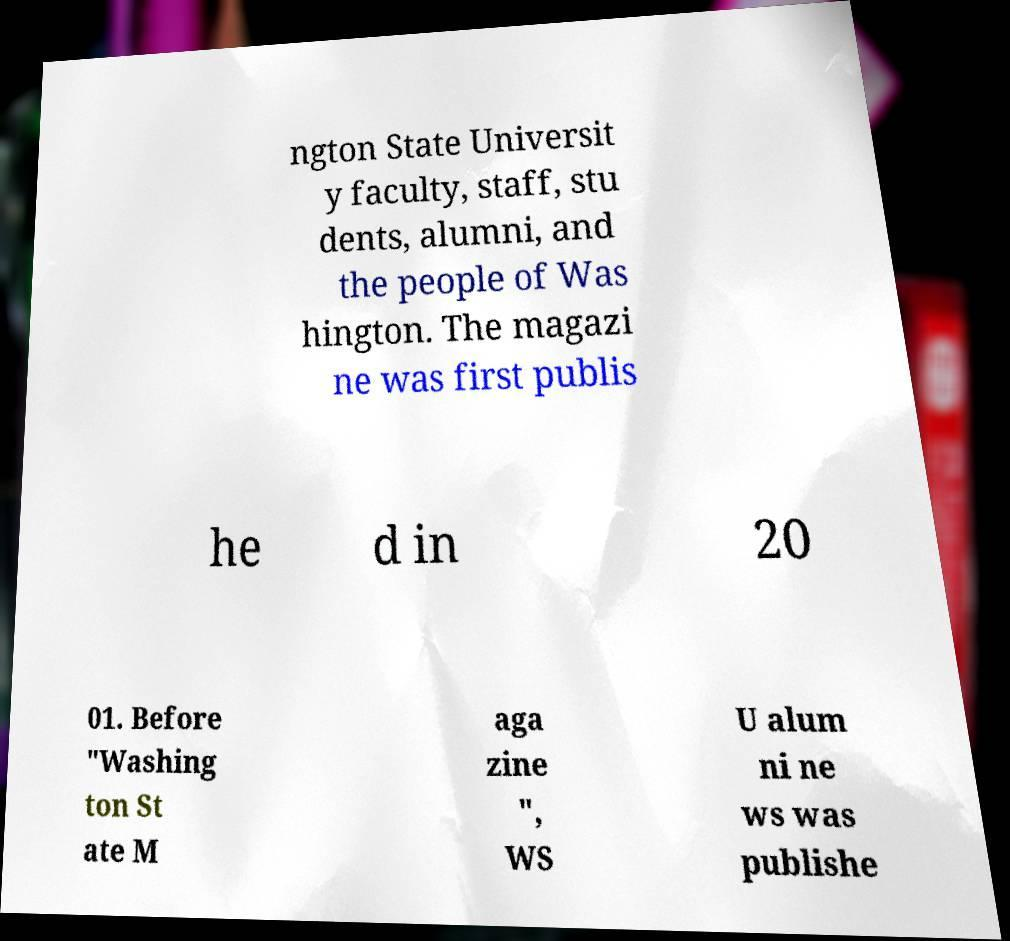Could you extract and type out the text from this image? ngton State Universit y faculty, staff, stu dents, alumni, and the people of Was hington. The magazi ne was first publis he d in 20 01. Before "Washing ton St ate M aga zine ", WS U alum ni ne ws was publishe 